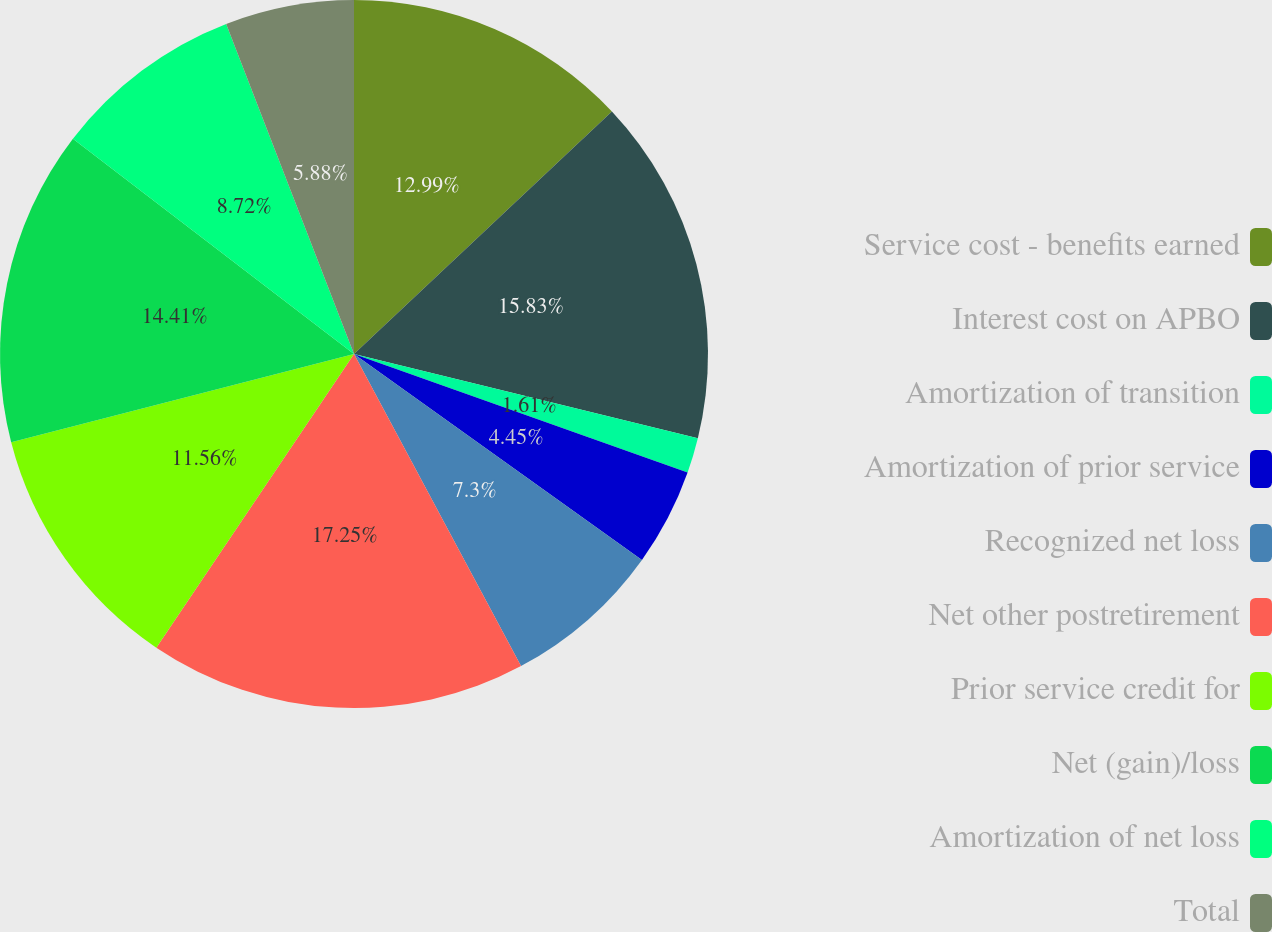Convert chart to OTSL. <chart><loc_0><loc_0><loc_500><loc_500><pie_chart><fcel>Service cost - benefits earned<fcel>Interest cost on APBO<fcel>Amortization of transition<fcel>Amortization of prior service<fcel>Recognized net loss<fcel>Net other postretirement<fcel>Prior service credit for<fcel>Net (gain)/loss<fcel>Amortization of net loss<fcel>Total<nl><fcel>12.99%<fcel>15.83%<fcel>1.61%<fcel>4.45%<fcel>7.3%<fcel>17.25%<fcel>11.56%<fcel>14.41%<fcel>8.72%<fcel>5.88%<nl></chart> 